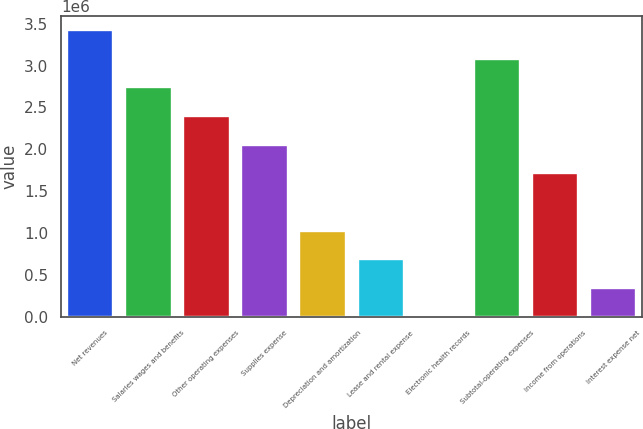Convert chart to OTSL. <chart><loc_0><loc_0><loc_500><loc_500><bar_chart><fcel>Net revenues<fcel>Salaries wages and benefits<fcel>Other operating expenses<fcel>Supplies expense<fcel>Depreciation and amortization<fcel>Lease and rental expense<fcel>Electronic health records<fcel>Subtotal-operating expenses<fcel>Income from operations<fcel>Interest expense net<nl><fcel>3.42396e+06<fcel>2.73917e+06<fcel>2.39677e+06<fcel>2.05438e+06<fcel>1.02719e+06<fcel>684794<fcel>2.91<fcel>3.08156e+06<fcel>1.71198e+06<fcel>342398<nl></chart> 